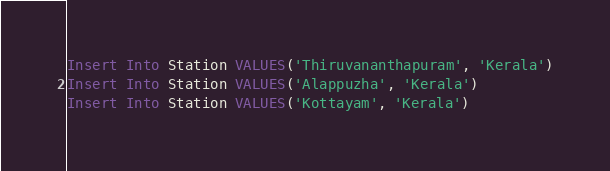Convert code to text. <code><loc_0><loc_0><loc_500><loc_500><_SQL_>
Insert Into Station VALUES('Thiruvananthapuram', 'Kerala')
Insert Into Station VALUES('Alappuzha', 'Kerala')
Insert Into Station VALUES('Kottayam', 'Kerala')
</code> 